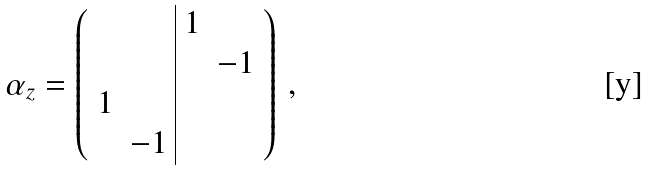Convert formula to latex. <formula><loc_0><loc_0><loc_500><loc_500>\alpha _ { z } = \left ( \begin{array} { c c | c c } & & 1 & \\ & & & - 1 \\ 1 & & & \\ & - 1 & & \end{array} \right ) \, ,</formula> 